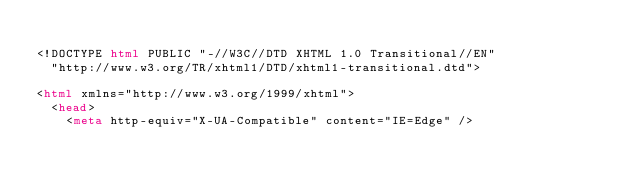<code> <loc_0><loc_0><loc_500><loc_500><_HTML_>
<!DOCTYPE html PUBLIC "-//W3C//DTD XHTML 1.0 Transitional//EN"
  "http://www.w3.org/TR/xhtml1/DTD/xhtml1-transitional.dtd">

<html xmlns="http://www.w3.org/1999/xhtml">
  <head>
    <meta http-equiv="X-UA-Compatible" content="IE=Edge" /></code> 